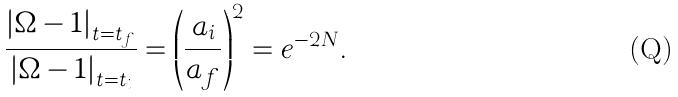<formula> <loc_0><loc_0><loc_500><loc_500>\frac { \left | \Omega - 1 \right | _ { t = t _ { f } } } { \left | \Omega - 1 \right | _ { t = t _ { i } } } = \left ( \frac { a _ { i } } { a _ { f } } \right ) ^ { 2 } = e ^ { - 2 N } .</formula> 